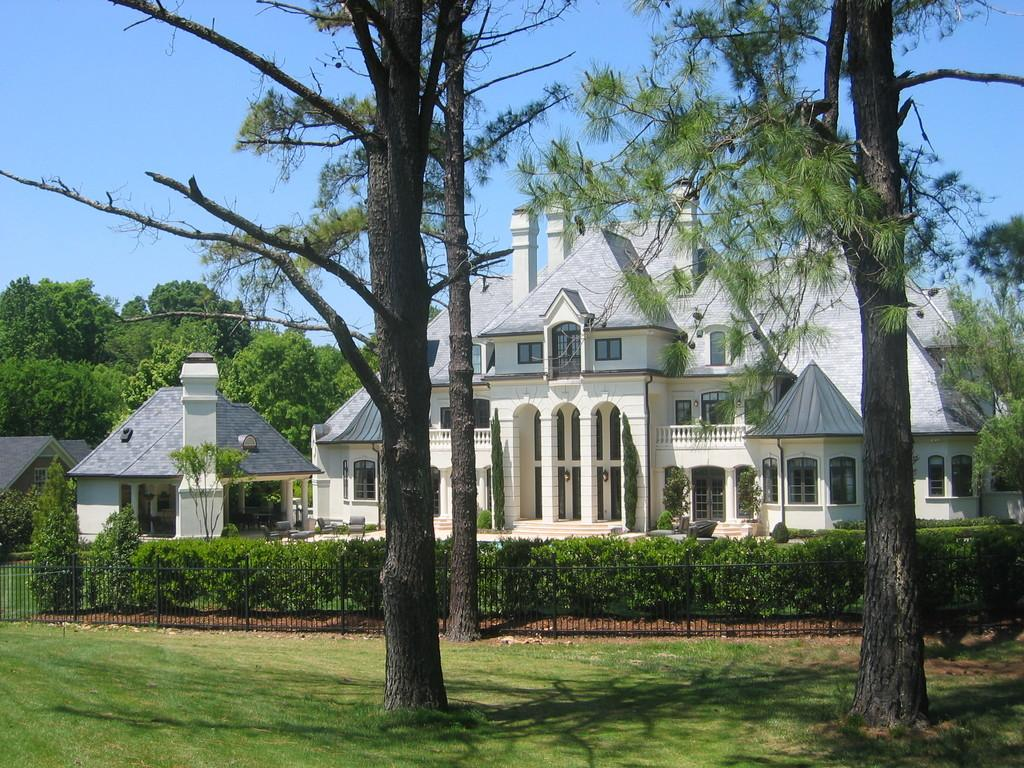What type of structures can be seen in the image? There are buildings in the image. What natural elements are present in the image? There are trees, plants, and grass on the ground in the image. What type of barrier is visible in the image? There is a metal fence in the image. What is the color of the sky in the image? The sky is blue in the image. Where is the pencil located in the image? There is no pencil present in the image. What is the limit of the grass in the image? The grass does not have a limit in the image; it is a continuous area of vegetation. 